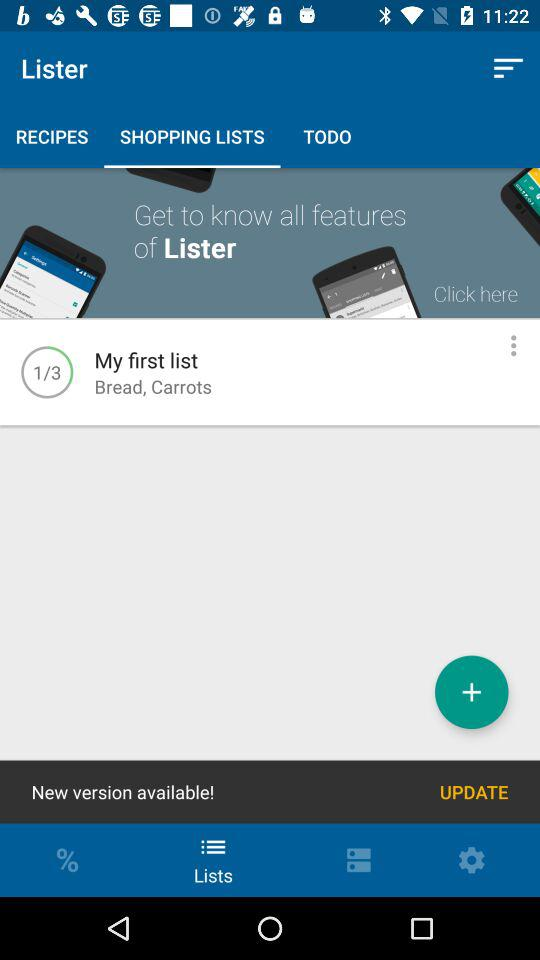At which list am I? You are at my first list. 